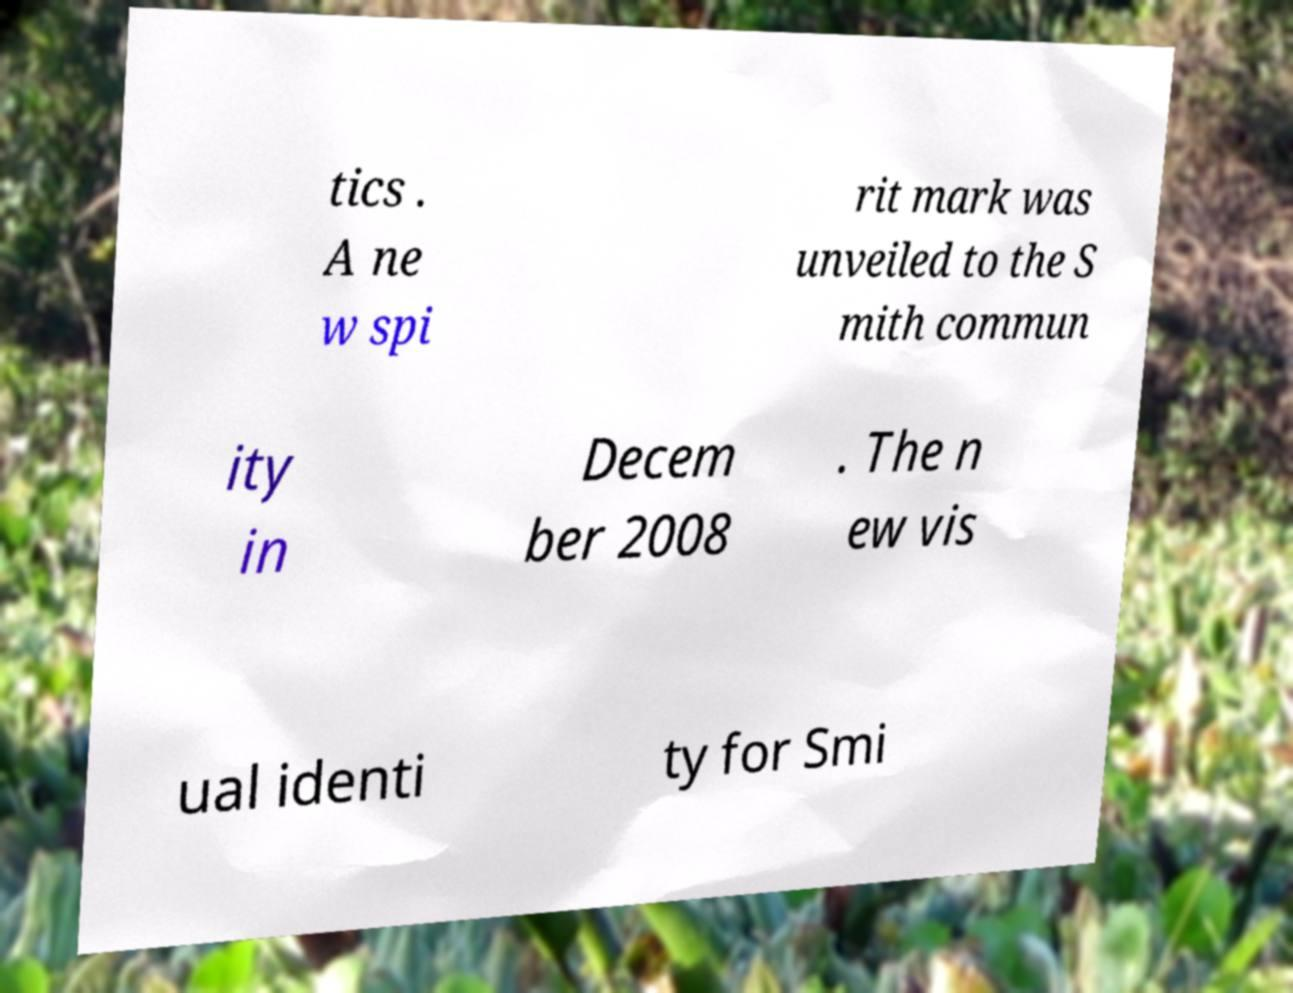For documentation purposes, I need the text within this image transcribed. Could you provide that? tics . A ne w spi rit mark was unveiled to the S mith commun ity in Decem ber 2008 . The n ew vis ual identi ty for Smi 